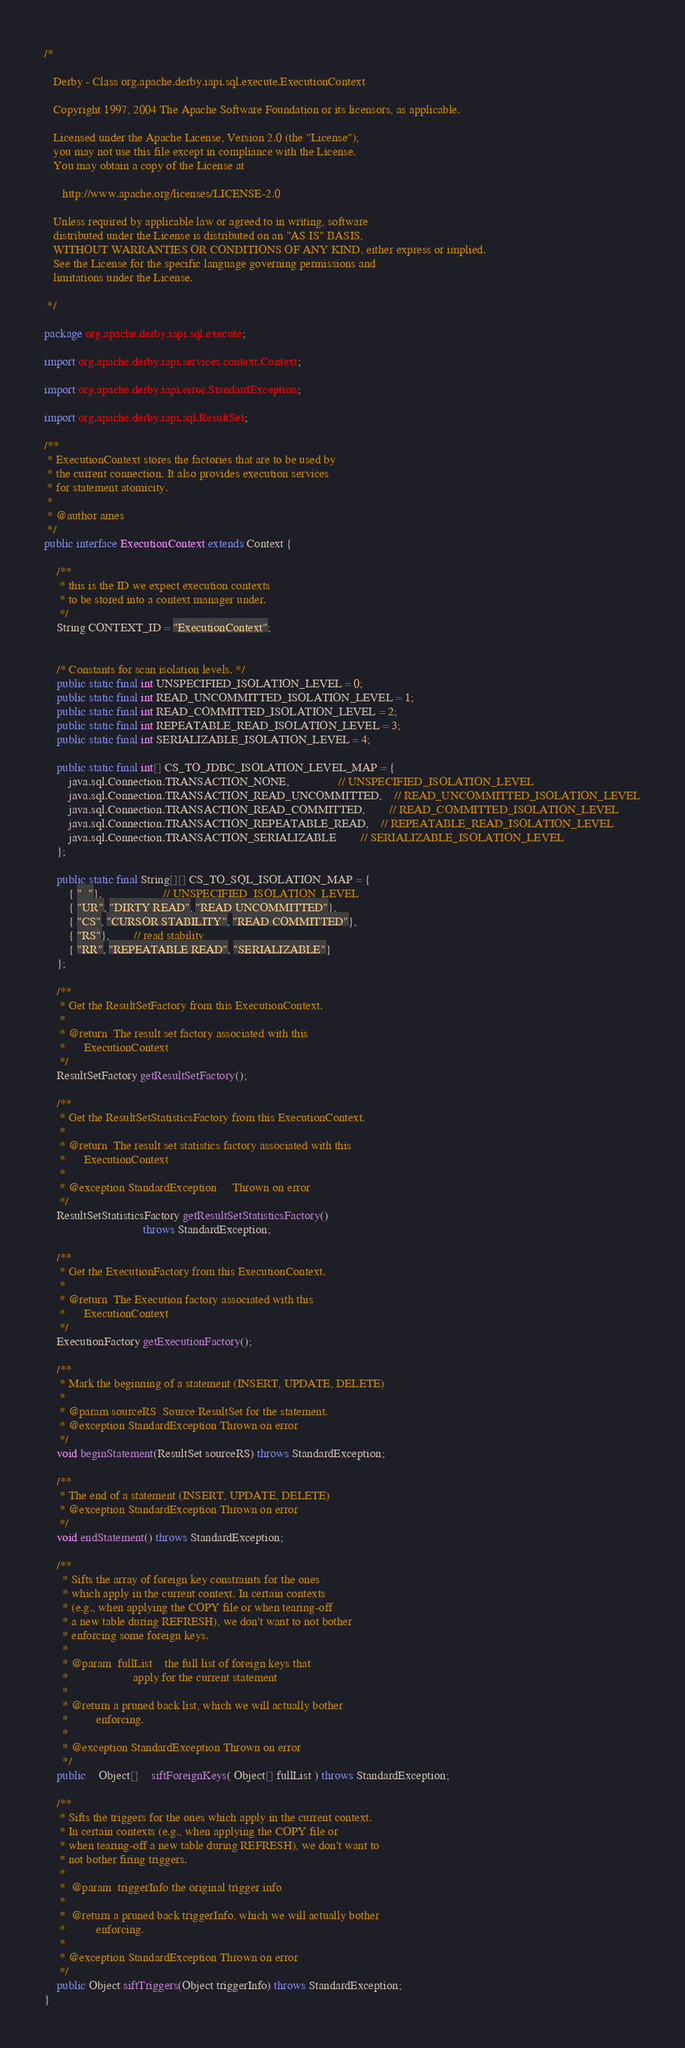<code> <loc_0><loc_0><loc_500><loc_500><_Java_>/*

   Derby - Class org.apache.derby.iapi.sql.execute.ExecutionContext

   Copyright 1997, 2004 The Apache Software Foundation or its licensors, as applicable.

   Licensed under the Apache License, Version 2.0 (the "License");
   you may not use this file except in compliance with the License.
   You may obtain a copy of the License at

      http://www.apache.org/licenses/LICENSE-2.0

   Unless required by applicable law or agreed to in writing, software
   distributed under the License is distributed on an "AS IS" BASIS,
   WITHOUT WARRANTIES OR CONDITIONS OF ANY KIND, either express or implied.
   See the License for the specific language governing permissions and
   limitations under the License.

 */

package org.apache.derby.iapi.sql.execute;

import org.apache.derby.iapi.services.context.Context;

import org.apache.derby.iapi.error.StandardException;

import org.apache.derby.iapi.sql.ResultSet;

/**
 * ExecutionContext stores the factories that are to be used by
 * the current connection. It also provides execution services
 * for statement atomicity.
 *
 * @author ames
 */
public interface ExecutionContext extends Context {

	/**
	 * this is the ID we expect execution contexts
	 * to be stored into a context manager under.
	 */
	String CONTEXT_ID = "ExecutionContext";
	
	
	/* Constants for scan isolation levels. */
	public static final int UNSPECIFIED_ISOLATION_LEVEL = 0;
	public static final int READ_UNCOMMITTED_ISOLATION_LEVEL = 1;
	public static final int READ_COMMITTED_ISOLATION_LEVEL = 2;
	public static final int REPEATABLE_READ_ISOLATION_LEVEL = 3;
	public static final int SERIALIZABLE_ISOLATION_LEVEL = 4;

	public static final int[] CS_TO_JDBC_ISOLATION_LEVEL_MAP = {
		java.sql.Connection.TRANSACTION_NONE,				// UNSPECIFIED_ISOLATION_LEVEL
		java.sql.Connection.TRANSACTION_READ_UNCOMMITTED,	// READ_UNCOMMITTED_ISOLATION_LEVEL
		java.sql.Connection.TRANSACTION_READ_COMMITTED,		// READ_COMMITTED_ISOLATION_LEVEL
		java.sql.Connection.TRANSACTION_REPEATABLE_READ,	// REPEATABLE_READ_ISOLATION_LEVEL		
		java.sql.Connection.TRANSACTION_SERIALIZABLE		// SERIALIZABLE_ISOLATION_LEVEL
	};

	public static final String[][] CS_TO_SQL_ISOLATION_MAP = {
		{ "  "},					// UNSPECIFIED_ISOLATION_LEVEL
		{ "UR", "DIRTY READ", "READ UNCOMMITTED"},
		{ "CS", "CURSOR STABILITY", "READ COMMITTED"},
		{ "RS"},		// read stability	
		{ "RR", "REPEATABLE READ", "SERIALIZABLE"}
	};

	/**
	 * Get the ResultSetFactory from this ExecutionContext.
	 *
	 * @return	The result set factory associated with this
	 *		ExecutionContext
	 */
	ResultSetFactory getResultSetFactory();

	/**
	 * Get the ResultSetStatisticsFactory from this ExecutionContext.
	 *
	 * @return	The result set statistics factory associated with this
	 *		ExecutionContext
	 *
	 * @exception StandardException		Thrown on error
	 */
	ResultSetStatisticsFactory getResultSetStatisticsFactory()
								throws StandardException;

	/**
	 * Get the ExecutionFactory from this ExecutionContext.
	 *
	 * @return	The Execution factory associated with this
	 *		ExecutionContext
	 */
	ExecutionFactory getExecutionFactory();

	/**
	 * Mark the beginning of a statement (INSERT, UPDATE, DELETE)
	 *
	 * @param sourceRS	Source ResultSet for the statement.
	 * @exception StandardException Thrown on error
	 */
	void beginStatement(ResultSet sourceRS) throws StandardException;

	/**
	 * The end of a statement (INSERT, UPDATE, DELETE)
	 * @exception StandardException Thrown on error
	 */
	void endStatement() throws StandardException;

	/**
	  *	Sifts the array of foreign key constraints for the ones
	  *	which apply in the current context. In certain contexts
	  *	(e.g., when applying the COPY file or when tearing-off
	  *	a new table during REFRESH), we don't want to not bother
	  *	enforcing some foreign keys.
	  *
	  *	@param	fullList	the full list of foreign keys that
	  *						apply for the current statement
	  *
	  *	@return	a pruned back list, which we will actually bother
	  *			enforcing.
	  *
	  * @exception StandardException Thrown on error
	  */
	public	Object[]	siftForeignKeys( Object[] fullList ) throws StandardException;

	/**
	 * Sifts the triggers for the ones which apply in the current context. 
	 * In certain contexts (e.g., when applying the COPY file or 
	 * when tearing-off a new table during REFRESH), we don't want to 
	 * not bother firing triggers.
	 * 
	 *	@param	triggerInfo	the original trigger info
	 *
	 *	@return	a pruned back triggerInfo, which we will actually bother
	 *			enforcing.
	 *
	 * @exception StandardException Thrown on error
	 */
	public Object siftTriggers(Object triggerInfo) throws StandardException;
}
</code> 